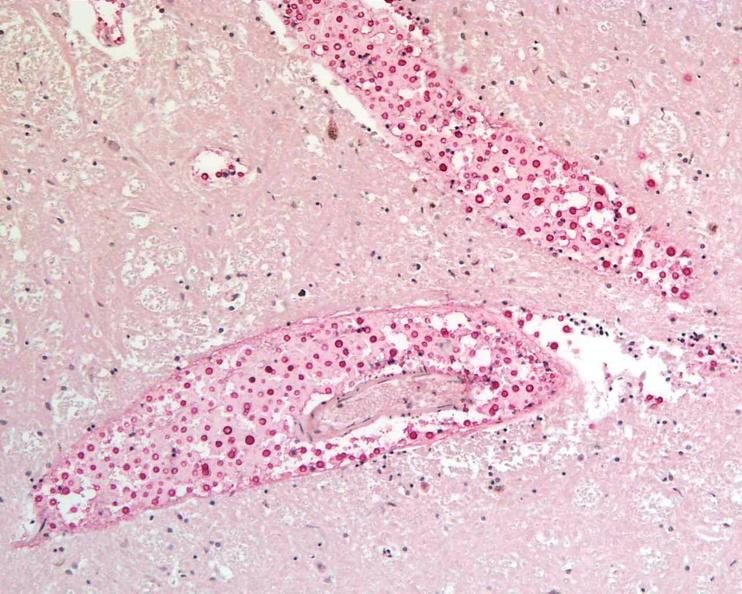s nervous present?
Answer the question using a single word or phrase. Yes 